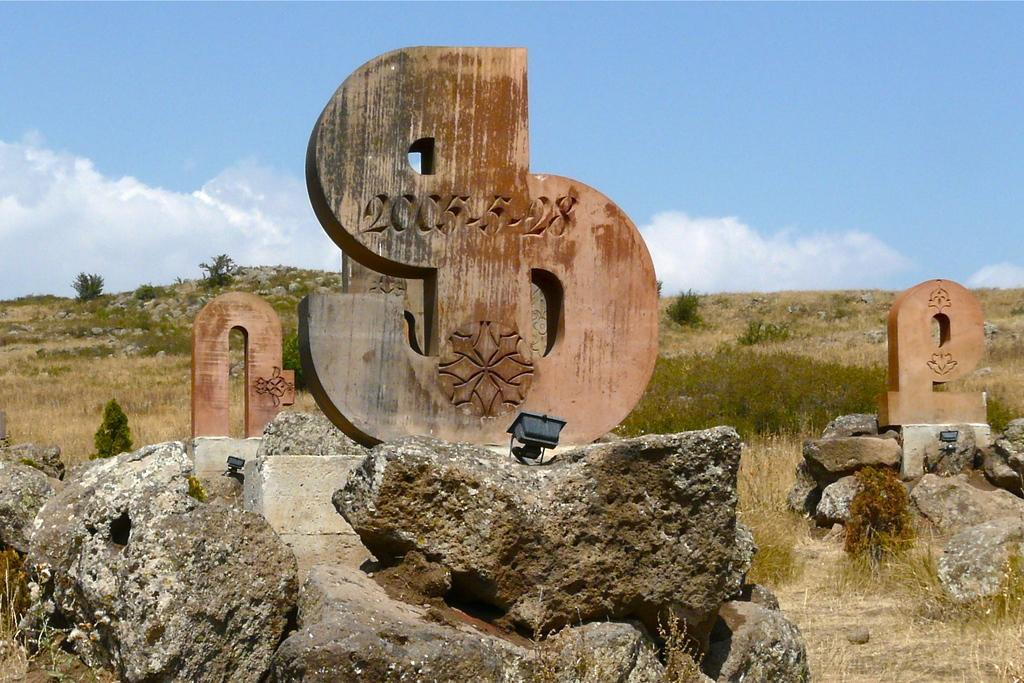What type of objects can be seen in the image? There are stones and wooden items in the image. What can be seen in the background of the image? The sky is visible in the background of the image. How many firemen are present in the image? There are no firemen present in the image. What type of insect can be seen interacting with the wooden items in the image? There are no insects, including beetles, visible in the image. 